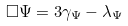<formula> <loc_0><loc_0><loc_500><loc_500>\Box \Psi = 3 \gamma _ { \Psi } - \lambda _ { \Psi }</formula> 